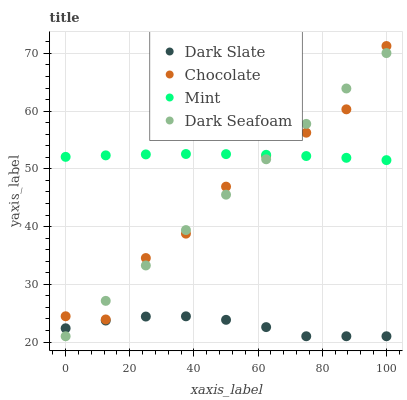Does Dark Slate have the minimum area under the curve?
Answer yes or no. Yes. Does Mint have the maximum area under the curve?
Answer yes or no. Yes. Does Dark Seafoam have the minimum area under the curve?
Answer yes or no. No. Does Dark Seafoam have the maximum area under the curve?
Answer yes or no. No. Is Dark Seafoam the smoothest?
Answer yes or no. Yes. Is Chocolate the roughest?
Answer yes or no. Yes. Is Mint the smoothest?
Answer yes or no. No. Is Mint the roughest?
Answer yes or no. No. Does Dark Slate have the lowest value?
Answer yes or no. Yes. Does Mint have the lowest value?
Answer yes or no. No. Does Chocolate have the highest value?
Answer yes or no. Yes. Does Dark Seafoam have the highest value?
Answer yes or no. No. Is Dark Slate less than Chocolate?
Answer yes or no. Yes. Is Mint greater than Dark Slate?
Answer yes or no. Yes. Does Dark Seafoam intersect Dark Slate?
Answer yes or no. Yes. Is Dark Seafoam less than Dark Slate?
Answer yes or no. No. Is Dark Seafoam greater than Dark Slate?
Answer yes or no. No. Does Dark Slate intersect Chocolate?
Answer yes or no. No. 